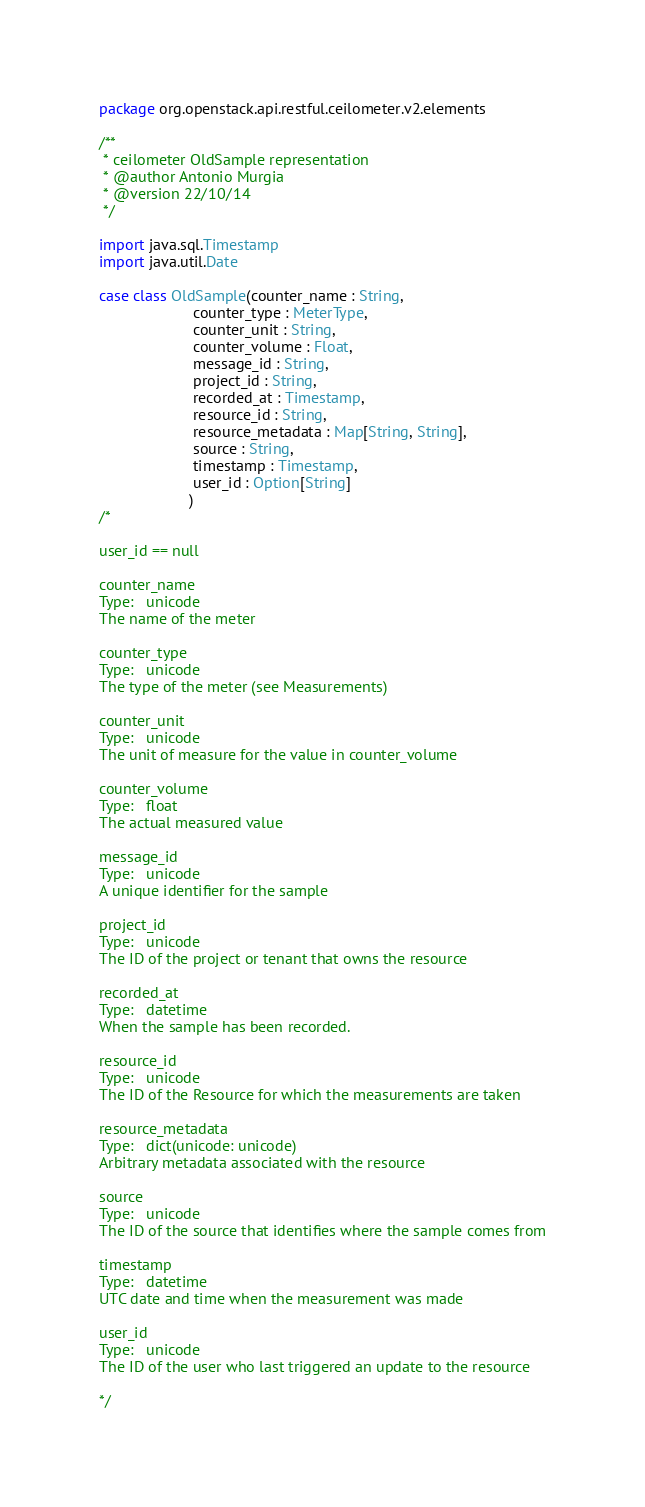<code> <loc_0><loc_0><loc_500><loc_500><_Scala_>package org.openstack.api.restful.ceilometer.v2.elements

/**
 * ceilometer OldSample representation
 * @author Antonio Murgia
 * @version 22/10/14
 */

import java.sql.Timestamp
import java.util.Date

case class OldSample(counter_name : String,
                      counter_type : MeterType,
                      counter_unit : String,
                      counter_volume : Float,
                      message_id : String,
                      project_id : String,
                      recorded_at : Timestamp,
                      resource_id : String,
                      resource_metadata : Map[String, String],
                      source : String,
                      timestamp : Timestamp,
                      user_id : Option[String]
                     )
/*

user_id == null

counter_name
Type:	unicode
The name of the meter

counter_type
Type:	unicode
The type of the meter (see Measurements)

counter_unit
Type:	unicode
The unit of measure for the value in counter_volume

counter_volume
Type:	float
The actual measured value

message_id
Type:	unicode
A unique identifier for the sample

project_id
Type:	unicode
The ID of the project or tenant that owns the resource

recorded_at
Type:	datetime
When the sample has been recorded.

resource_id
Type:	unicode
The ID of the Resource for which the measurements are taken

resource_metadata
Type:	dict(unicode: unicode)
Arbitrary metadata associated with the resource

source
Type:	unicode
The ID of the source that identifies where the sample comes from

timestamp
Type:	datetime
UTC date and time when the measurement was made

user_id
Type:	unicode
The ID of the user who last triggered an update to the resource

*/</code> 